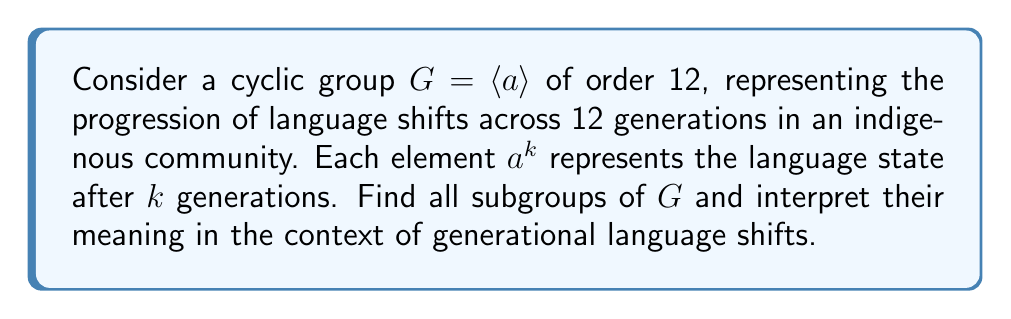Help me with this question. To find the subgroups of the cyclic group $G = \langle a \rangle$ of order 12, we need to consider the divisors of 12. The order of each subgroup must divide the order of the group.

1) The divisors of 12 are 1, 2, 3, 4, 6, and 12.

2) For each divisor $d$, there is a unique subgroup of order $d$, generated by $a^{12/d}$.

3) Let's find each subgroup:

   - For $d = 1$: $\langle a^{12} \rangle = \{e\}$ (trivial subgroup)
   - For $d = 2$: $\langle a^6 \rangle = \{e, a^6\}$
   - For $d = 3$: $\langle a^4 \rangle = \{e, a^4, a^8\}$
   - For $d = 4$: $\langle a^3 \rangle = \{e, a^3, a^6, a^9\}$
   - For $d = 6$: $\langle a^2 \rangle = \{e, a^2, a^4, a^6, a^8, a^{10}\}$
   - For $d = 12$: $\langle a \rangle = G$ (the entire group)

4) Interpretation in the context of language shifts:

   - $\{e\}$: No language change
   - $\langle a^6 \rangle$: Language alternates between two states every 6 generations
   - $\langle a^4 \rangle$: Language cycles through 3 states every 4 generations
   - $\langle a^3 \rangle$: Language cycles through 4 states every 3 generations
   - $\langle a^2 \rangle$: Language cycles through 6 states every 2 generations
   - $G$: Full 12-generation cycle of language states
Answer: The subgroups of $G$ are:
$\{e\}$, $\langle a^6 \rangle$, $\langle a^4 \rangle$, $\langle a^3 \rangle$, $\langle a^2 \rangle$, and $G$,
representing various cyclic patterns of language shifts across generations. 